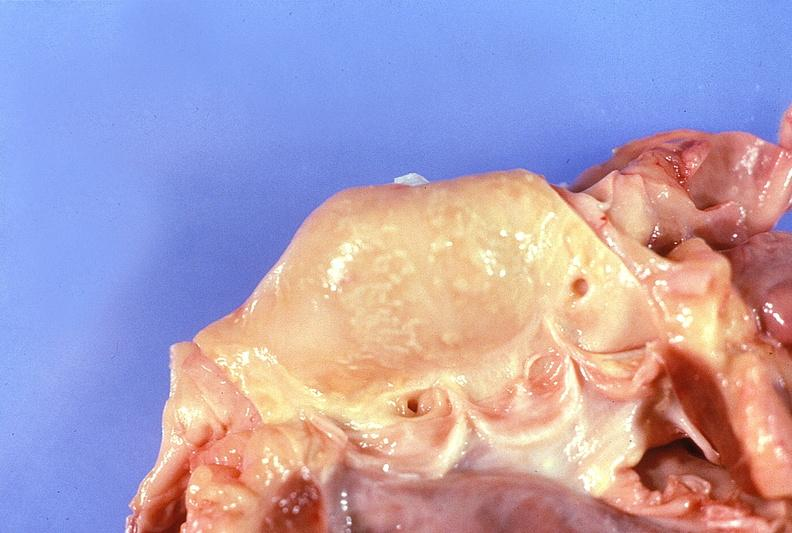what does this image show?
Answer the question using a single word or phrase. Normal aortic valve 